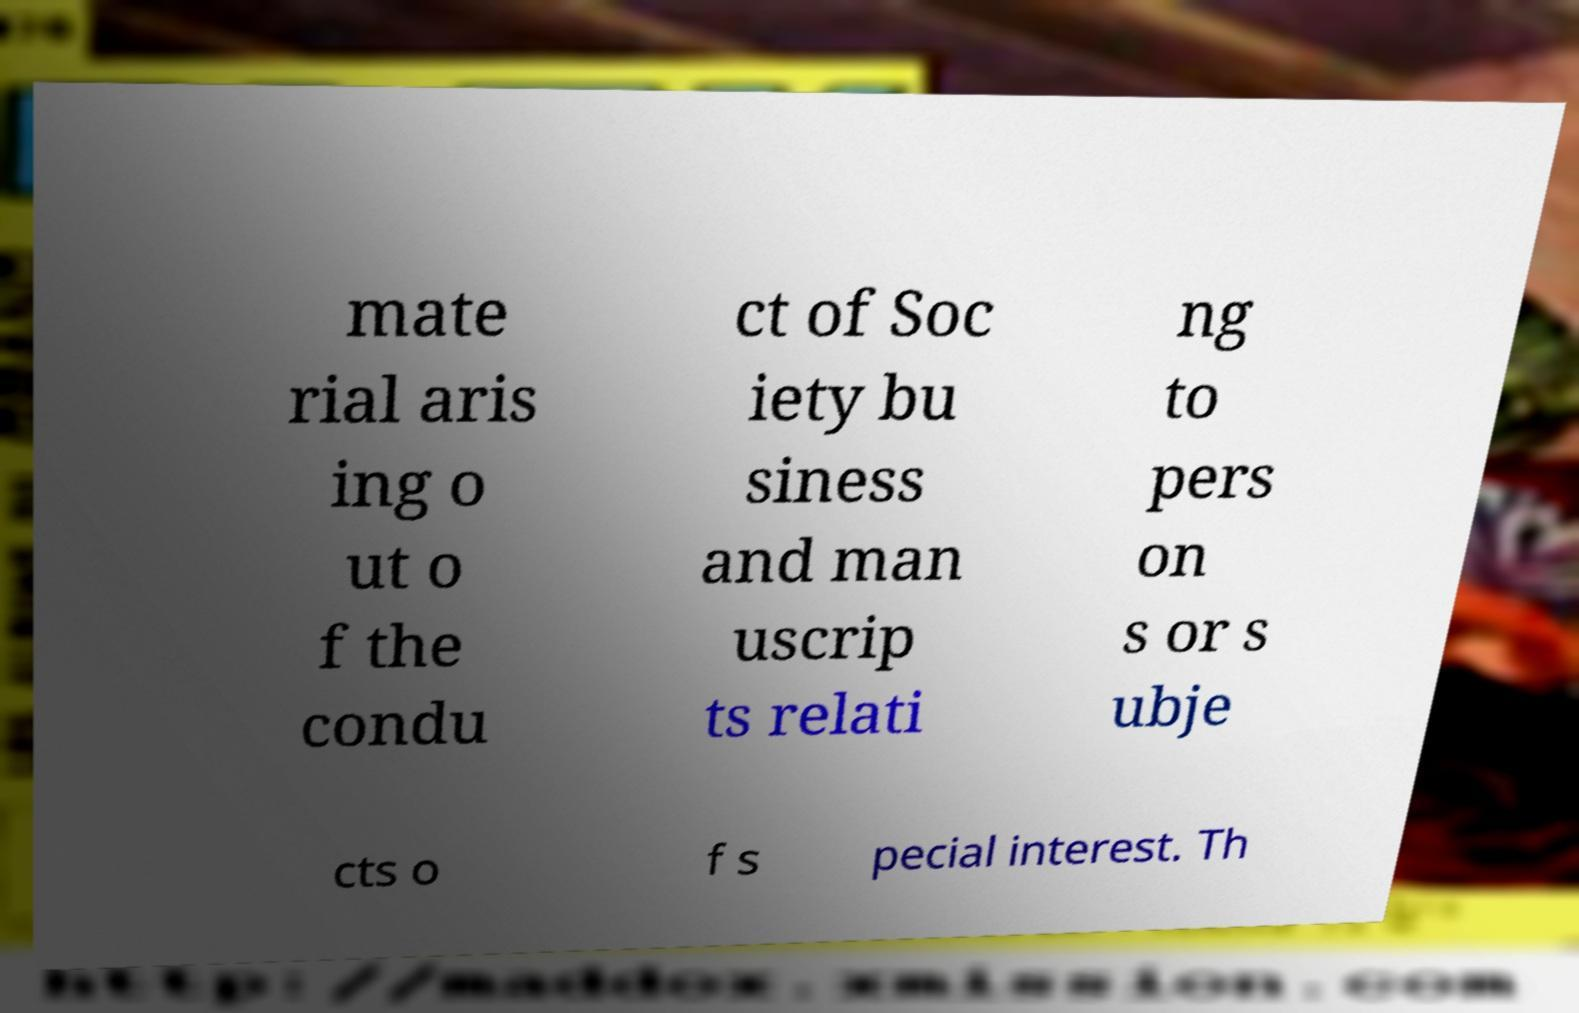Please identify and transcribe the text found in this image. mate rial aris ing o ut o f the condu ct of Soc iety bu siness and man uscrip ts relati ng to pers on s or s ubje cts o f s pecial interest. Th 